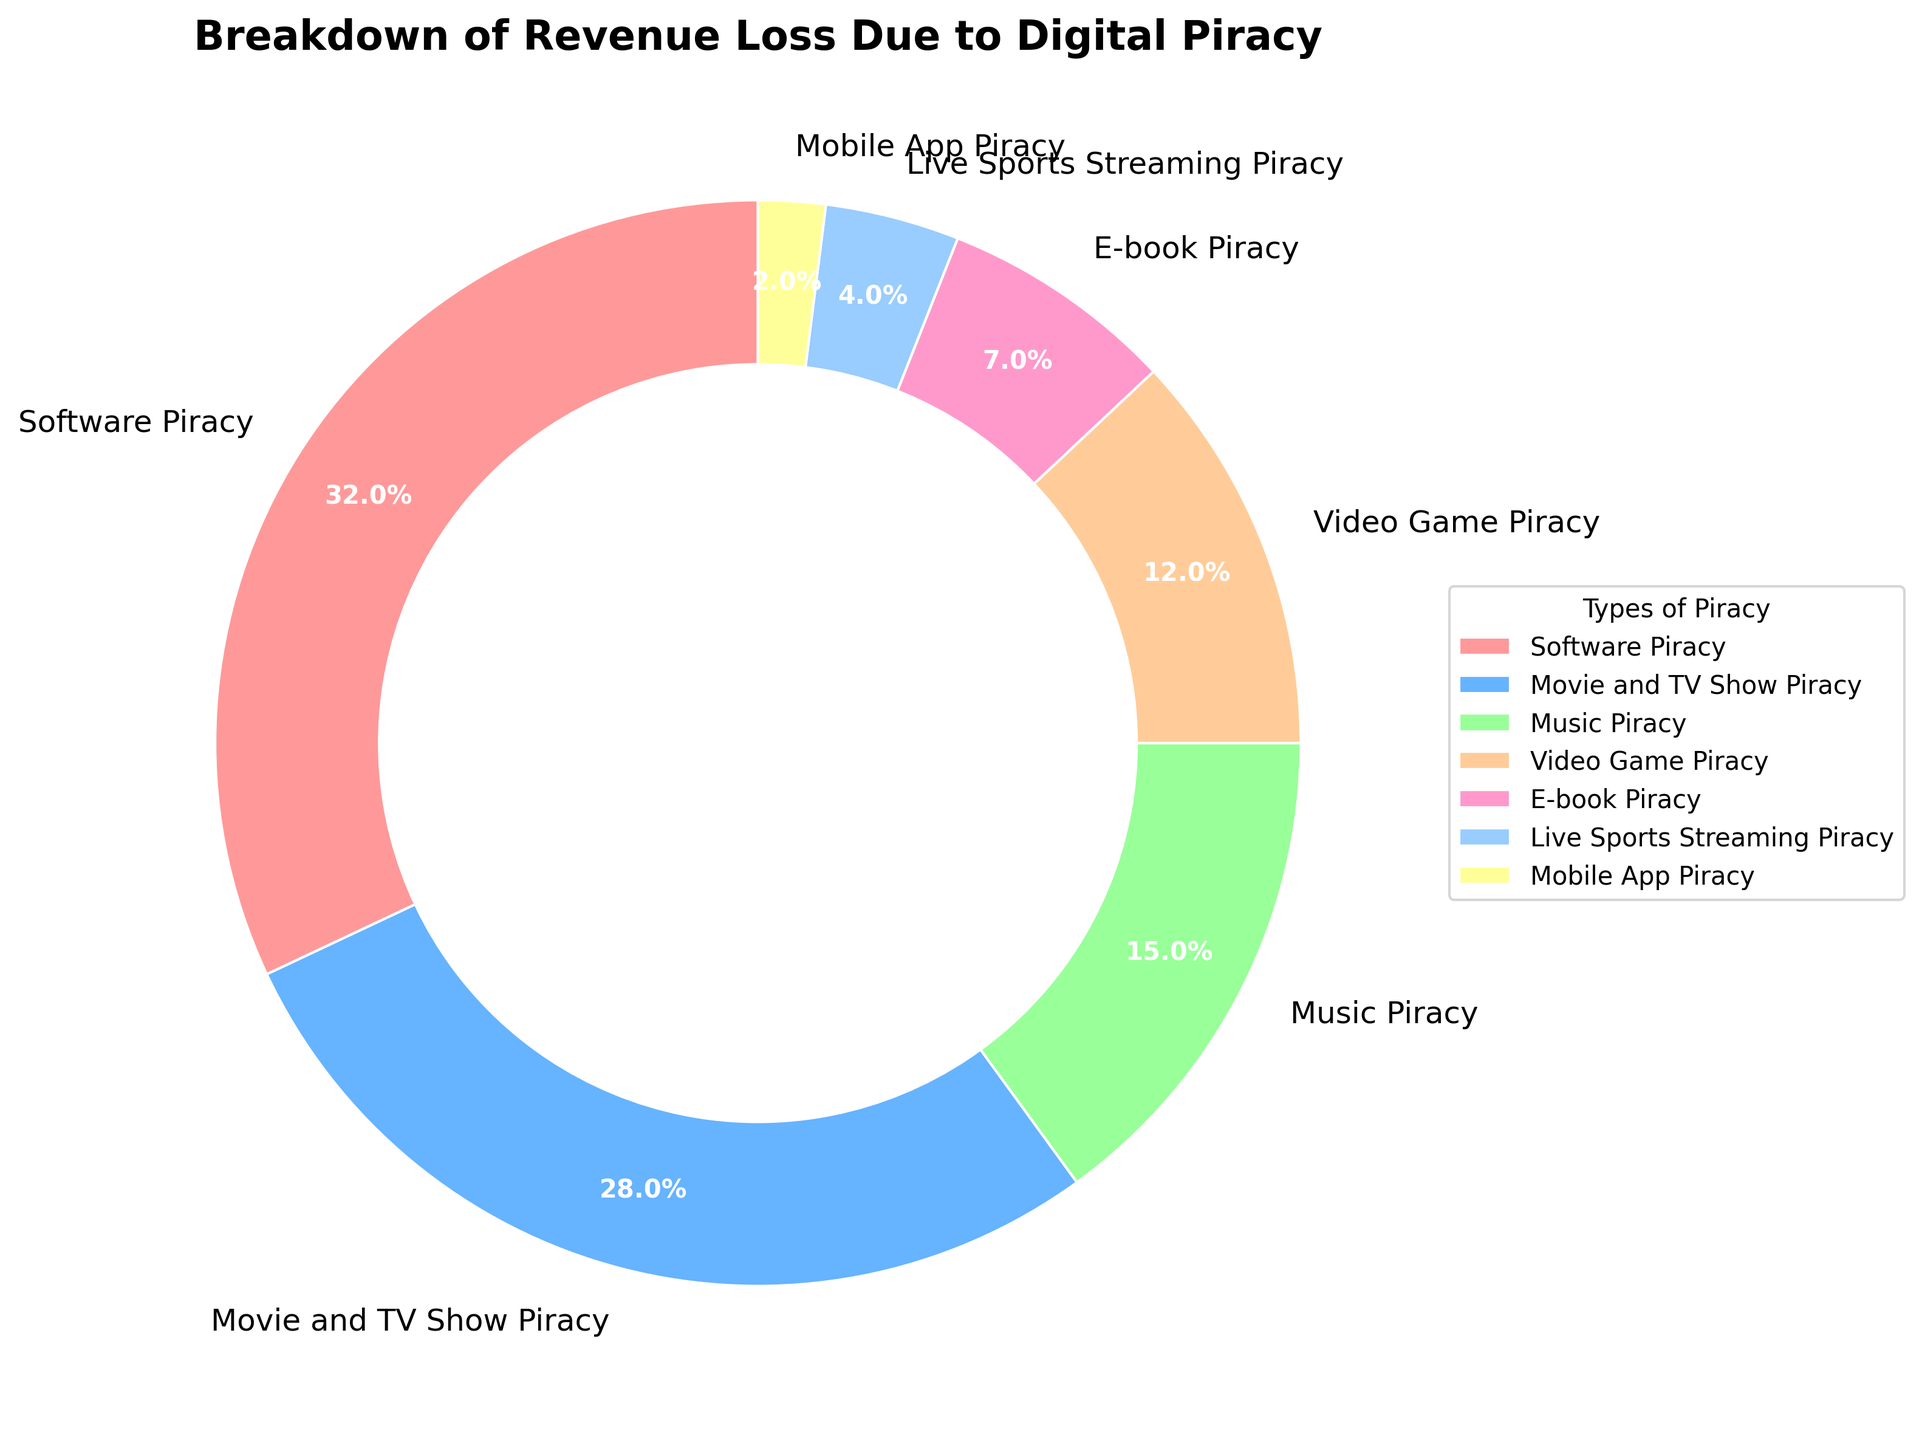What type of piracy accounts for the largest percentage of revenue loss? From the figure, identify the segment of the pie chart that represents the largest portion. The label for this segment indicates the category with the greatest revenue loss.
Answer: Software Piracy Which type of piracy results in less revenue loss, Music Piracy or Video Game Piracy? Compare the percentage values associated with Music Piracy and Video Game Piracy segments of the pie chart.
Answer: Video Game Piracy What is the combined revenue loss percentage for Music Piracy and E-book Piracy? Add the percentages shown for Music Piracy and E-book Piracy from the pie chart segments: 15% + 7%.
Answer: 22% How much greater is the revenue loss percentage from Movie and TV Show Piracy than from Mobile App Piracy? Subtract the percentage of Mobile App Piracy from the percentage of Movie and TV Show Piracy: 28% - 2%.
Answer: 26% What is the total revenue loss percentage due to Software Piracy, Movie and TV Show Piracy, and Music Piracy combined? Sum the percentages of Software Piracy, Movie and TV Show Piracy, and Music Piracy segments: 32% + 28% + 15%.
Answer: 75% Between Live Sports Streaming Piracy and Mobile App Piracy, which is represented by a larger segment in the pie chart? Compare the size and percentage labels of the segments representing Live Sports Streaming Piracy and Mobile App Piracy.
Answer: Live Sports Streaming Piracy How do the revenue loss percentages of Video Game Piracy and Music Piracy compare? Look at the pie chart segments for Video Game Piracy and Music Piracy and compare their percentages: 12% vs 15%.
Answer: Music Piracy is higher by 3% What percentage of revenue loss is attributed to the least common type of piracy? Identify the segment in the pie chart with the smallest percentage, which represents the least common type of piracy.
Answer: 2% 